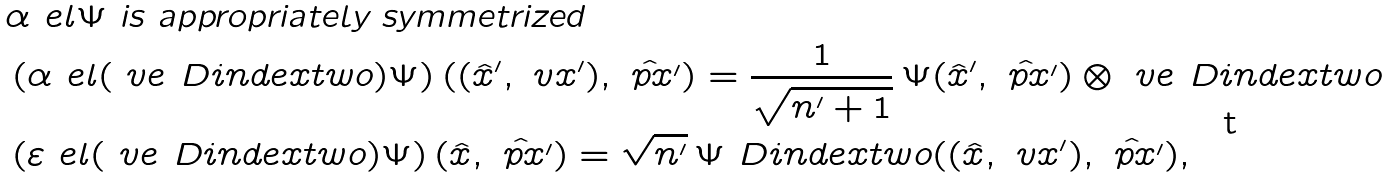<formula> <loc_0><loc_0><loc_500><loc_500>& \alpha _ { \ } e l \Psi \text { is appropriately symmetrized} \\ & \left ( \alpha _ { \ } e l ( \ v e _ { \ } D i n d e x t w o ) \Psi \right ) ( ( \hat { x } ^ { \prime } , \ v x ^ { \prime } ) , \hat { \ p x ^ { \prime } } ) = \frac { 1 } { \sqrt { n ^ { \prime } + 1 } } \, \Psi ( \hat { x } ^ { \prime } , \hat { \ p x ^ { \prime } } ) \otimes \ v e _ { \ } D i n d e x t w o \\ & \left ( \varepsilon _ { \ } e l ( \ v e _ { \ } D i n d e x t w o ) \Psi \right ) ( \hat { x } , \hat { \ p x ^ { \prime } } ) = \sqrt { n ^ { \prime } } \, \Psi _ { \ } D i n d e x t w o ( ( \hat { x } , \ v x ^ { \prime } ) , \hat { \ p x ^ { \prime } } ) ,</formula> 